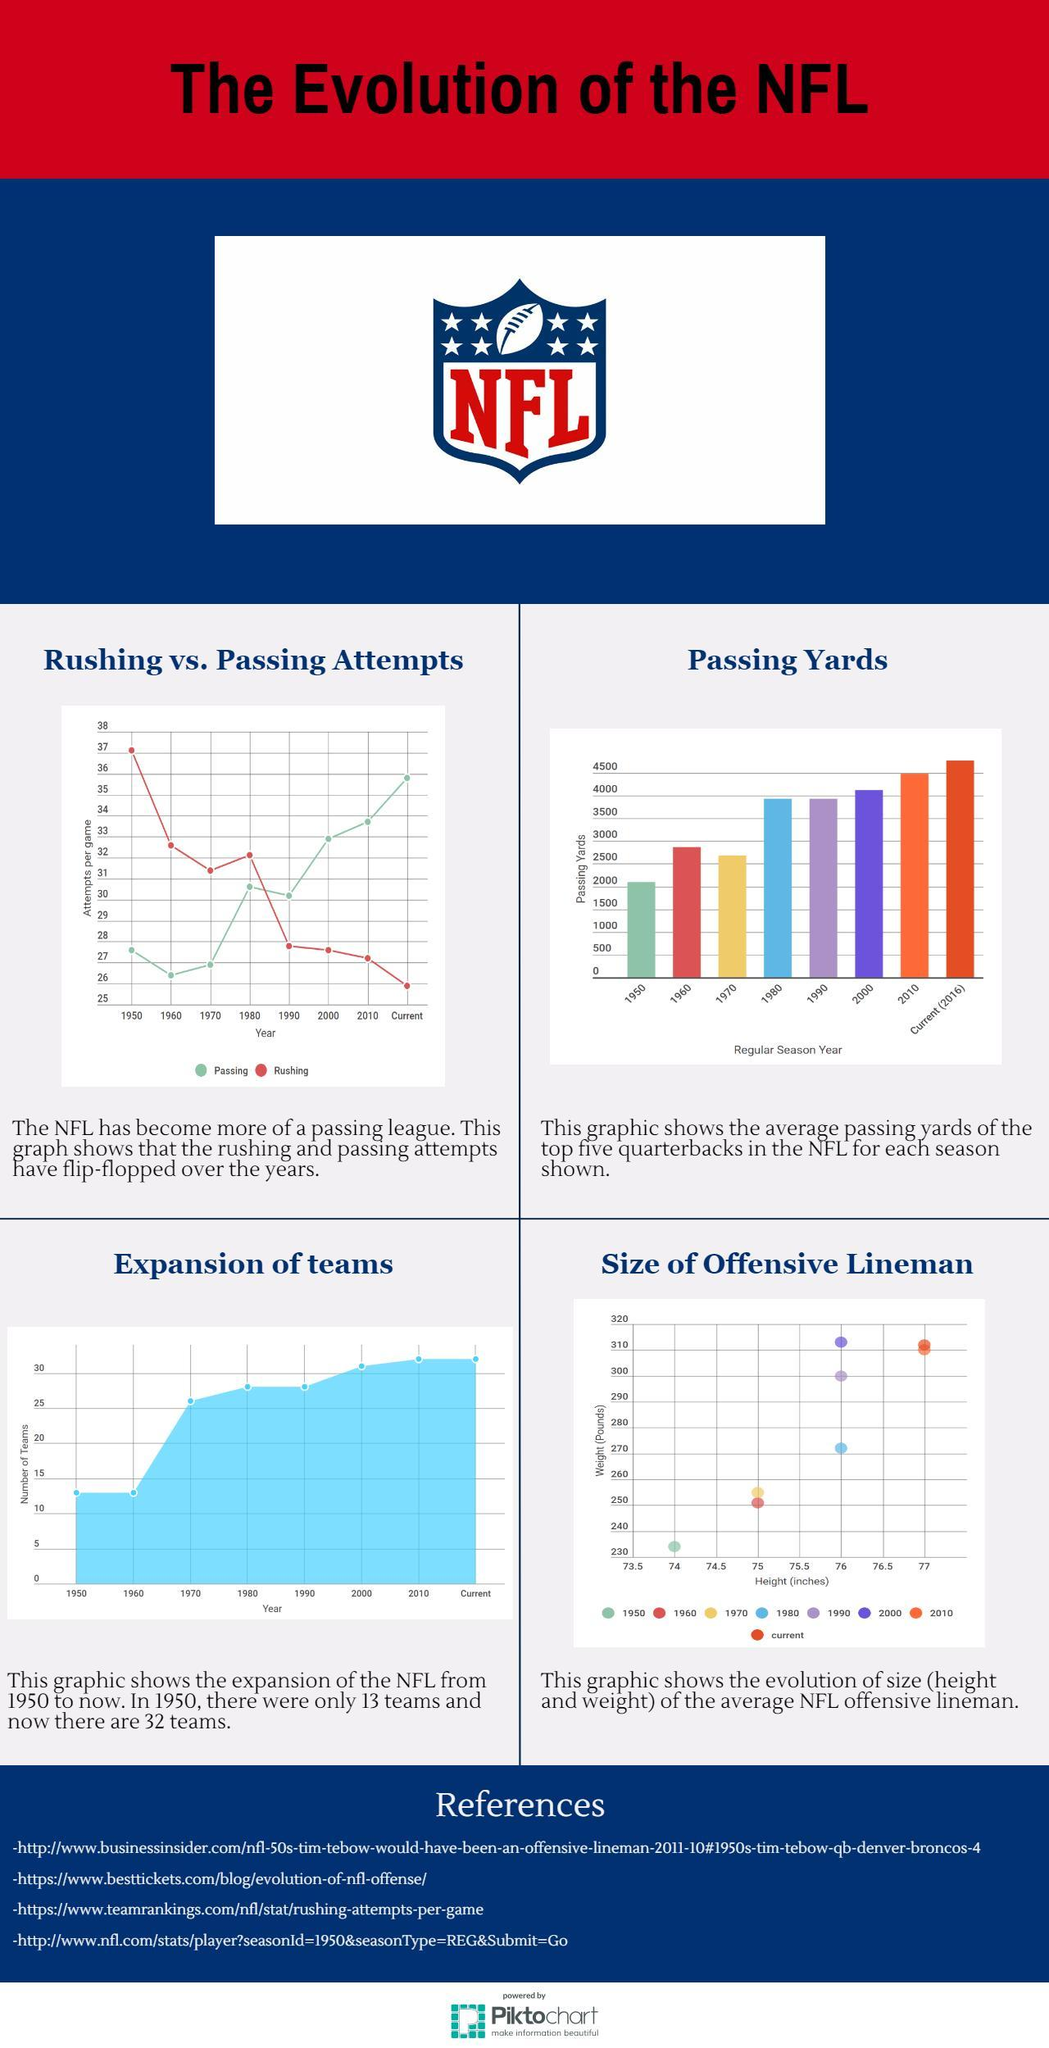Which year recorded the lowest weight and height of the offensive line man?
Answer the question with a short phrase. 1950 Which year had the second lowest passing attempt per game? 1970 What was the height of linemen in 1970 and 1960? 75 inches Which year recorded the highest weight and height of the players? 2000 What was the drop in number of rushing attempts per game in from 1980's until the present year? 6 What was the weight of linemen in 1990? 300 pounds What was the passing yards average in 1980 and 1990? 3900 What were the number of teams in NFL during 1970? 26 